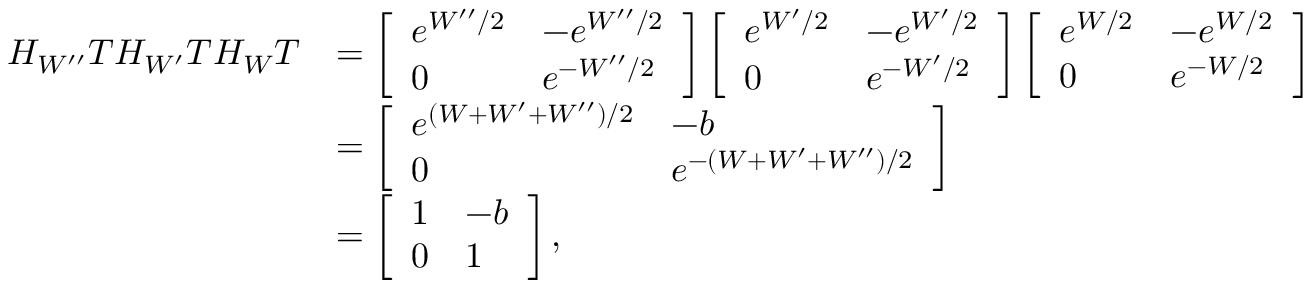<formula> <loc_0><loc_0><loc_500><loc_500>\begin{array} { r l } { H _ { W ^ { \prime \prime } } T H _ { W ^ { \prime } } T H _ { W } T } & { = \left [ \begin{array} { l l } { e ^ { W ^ { \prime \prime } / 2 } } & { - e ^ { W ^ { \prime \prime } / 2 } } \\ { 0 } & { e ^ { - W ^ { \prime \prime } / 2 } } \end{array} \right ] \left [ \begin{array} { l l } { e ^ { W ^ { \prime } / 2 } } & { - e ^ { W ^ { \prime } / 2 } } \\ { 0 } & { e ^ { - W ^ { \prime } / 2 } } \end{array} \right ] \left [ \begin{array} { l l } { e ^ { W / 2 } } & { - e ^ { W / 2 } } \\ { 0 } & { e ^ { - W / 2 } } \end{array} \right ] } \\ & { = \left [ \begin{array} { l l } { e ^ { ( W + W ^ { \prime } + W ^ { \prime \prime } ) / 2 } } & { - b } \\ { 0 } & { e ^ { - ( W + W ^ { \prime } + W ^ { \prime \prime } ) / 2 } } \end{array} \right ] } \\ & { = \left [ \begin{array} { l l } { 1 } & { - b } \\ { 0 } & { 1 } \end{array} \right ] , } \end{array}</formula> 